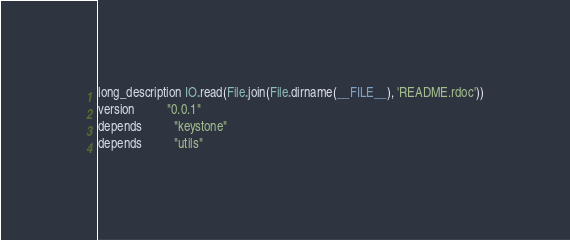<code> <loc_0><loc_0><loc_500><loc_500><_Ruby_>long_description IO.read(File.join(File.dirname(__FILE__), 'README.rdoc'))
version          "0.0.1"
depends          "keystone"
depends          "utils"
</code> 